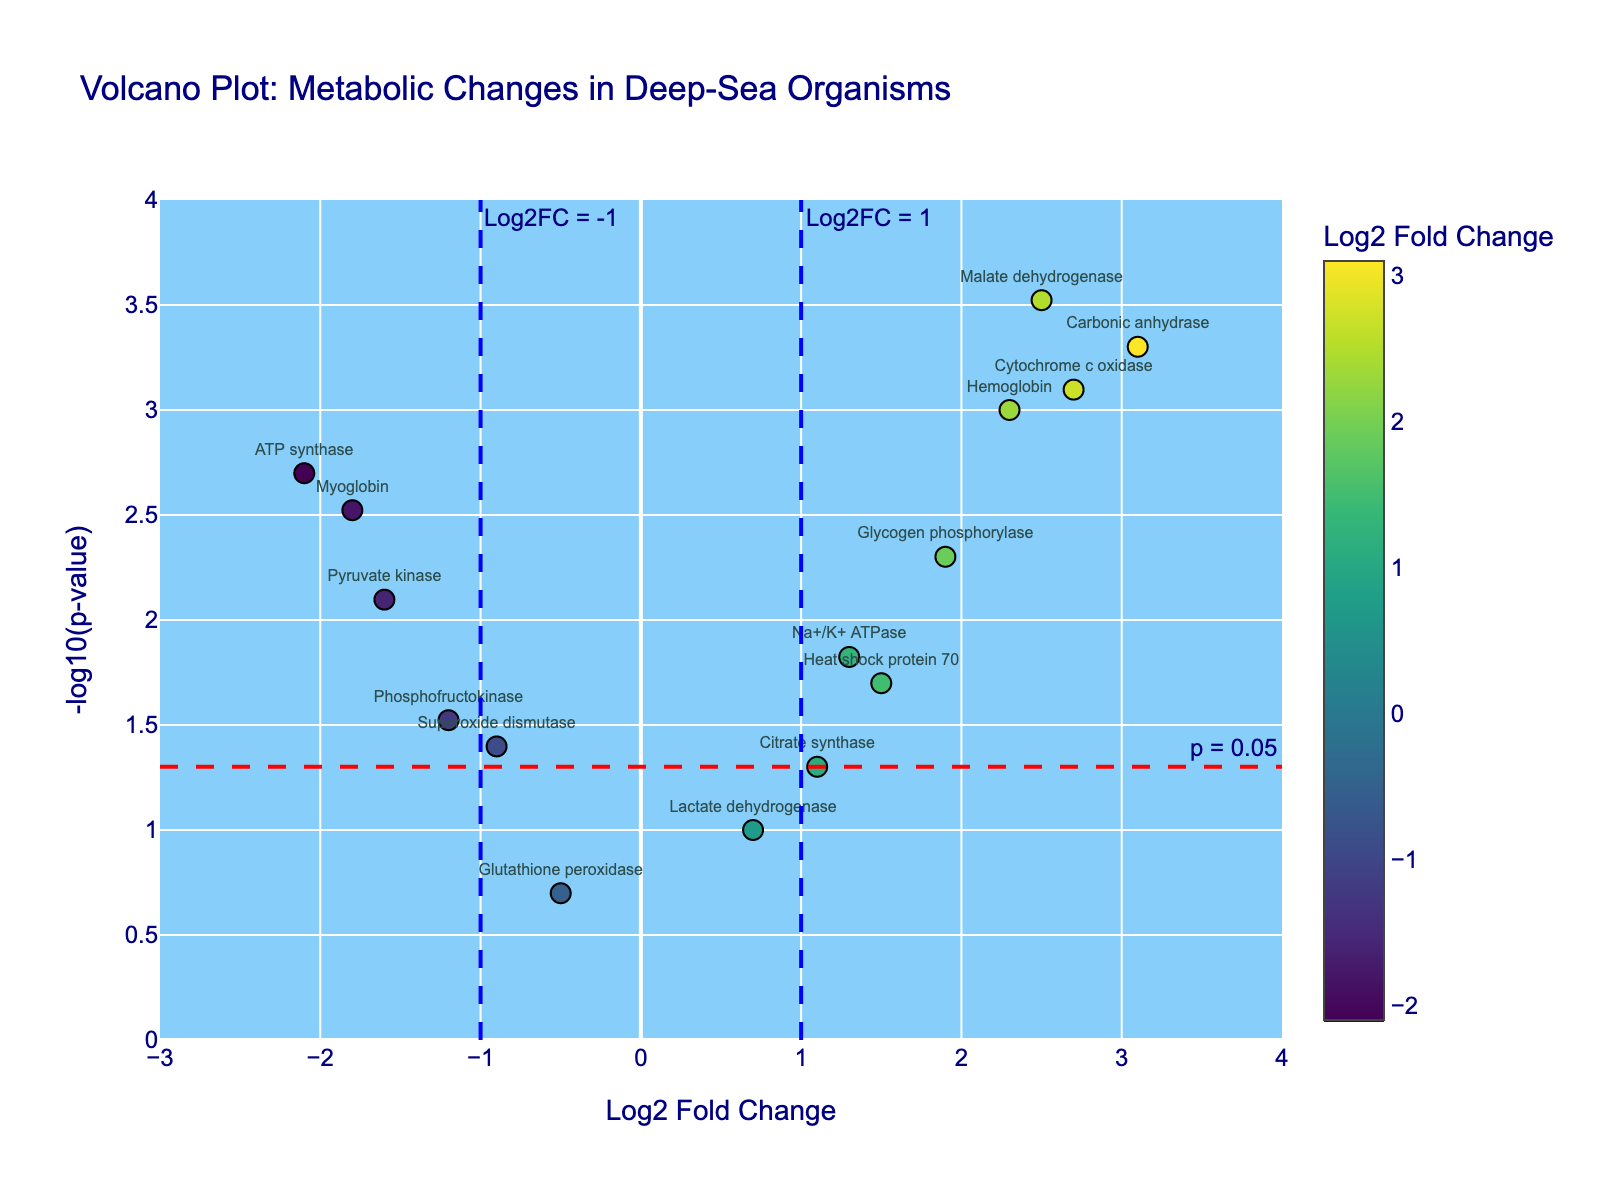Which gene has the highest Log2 Fold Change? Look for the gene with the maximum value on the x-axis (Log2 Fold Change). Carbonic anhydrase is the farthest to the right, indicating the highest value.
Answer: Carbonic anhydrase How many genes have a Log2 Fold Change greater than 1 and a p-value less than 0.05? Identify genes with Log2 Fold Change values to the right of the blue line at x=1 and above the red line at y=-log10(0.05). Genes are: Hemoglobin, Carbonic anhydrase, Cytochrome c oxidase, Glycogen phosphorylase, Malate dehydrogenase.
Answer: 5 Which gene has the lowest Log2 Fold Change while having a p-value less than 0.05? Find the lowest x-axis (Log2 Fold Change) among the genes above the red line at y=-log10(0.05). ATP synthase has the lowest value on the left side of the plot.
Answer: ATP synthase What is the p-value threshold shown in the plot? The red dashed line crosses the y-axis at a specific position. The annotation text says "p = 0.05".
Answer: 0.05 Which gene is closest to having a Log2 Fold Change of 0? Identify the gene nearest to where the x-axis intersects y=0. Lactate dehydrogenase is closest to x=0.
Answer: Lactate dehydrogenase Can you name a gene with a Log2 Fold Change less than -1 that also has a highly significant p-value? Look to the left of the blue line at x=-1 and identify any genes above the red line at y=-log10(0.05). Myoglobin and ATP synthase both qualify, but ATP synthase has a more significant p-value.
Answer: ATP synthase Does any gene with a positive Log2 Fold Change not cross the p-value significance threshold? Check for genes to the right of the y-axis (Log2 Fold Change > 0) that are below the red dashed line (-log10(0.05)). Heat shock protein 70 and Na+/K+ ATPase fit this criterion.
Answer: Yes Which gene has the lowest significance (highest p-value) among those listed? Identify the gene with the lowest y-axis position (-log10(p-value)). Glutathione peroxidase is the gene with the lowest -log10(p-value).
Answer: Glutathione peroxidase What is the range of Log2 Fold Change values displayed on the x-axis? The x-axis ranges from -3 to 4, as indicated by the axis limits of the plot.
Answer: -3 to 4 